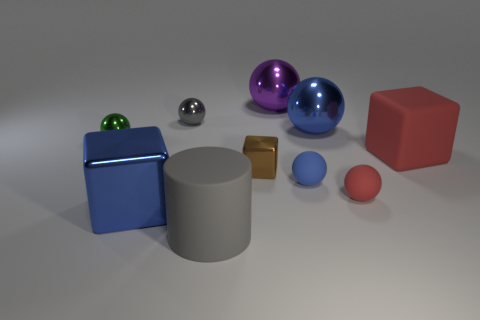How many other things are there of the same color as the cylinder?
Your answer should be compact. 1. Is the number of purple spheres that are in front of the large red rubber object less than the number of big blue things?
Make the answer very short. Yes. Is there a blue shiny block of the same size as the rubber block?
Ensure brevity in your answer.  Yes. There is a cylinder; is it the same color as the metal ball that is to the right of the purple object?
Provide a succinct answer. No. What number of tiny objects are behind the block on the left side of the gray cylinder?
Provide a succinct answer. 5. What is the color of the large matte thing behind the blue object to the left of the tiny block?
Ensure brevity in your answer.  Red. What material is the big thing that is both left of the big purple thing and behind the large gray cylinder?
Make the answer very short. Metal. Are there any blue metal objects of the same shape as the purple metal thing?
Provide a short and direct response. Yes. Is the shape of the red matte thing that is to the left of the large red object the same as  the blue matte object?
Your answer should be compact. Yes. How many large blue metallic things are behind the tiny brown shiny thing and left of the tiny blue ball?
Your answer should be very brief. 0. 